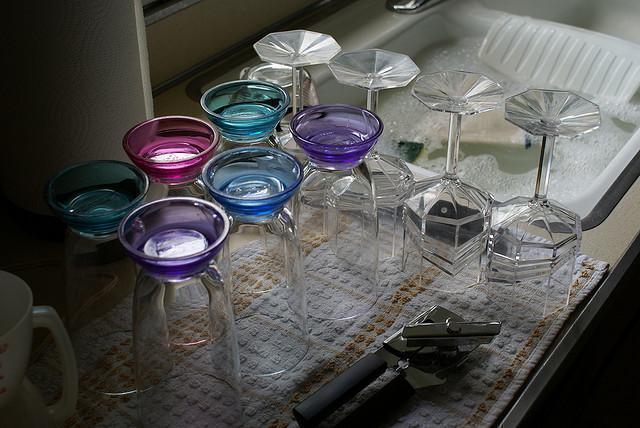Why are the glasses on a rag next to the sink?
Pick the right solution, then justify: 'Answer: answer
Rationale: rationale.'
Options: To sell, for dinner, storage, just washed. Answer: just washed.
Rationale: They are there to dry off 